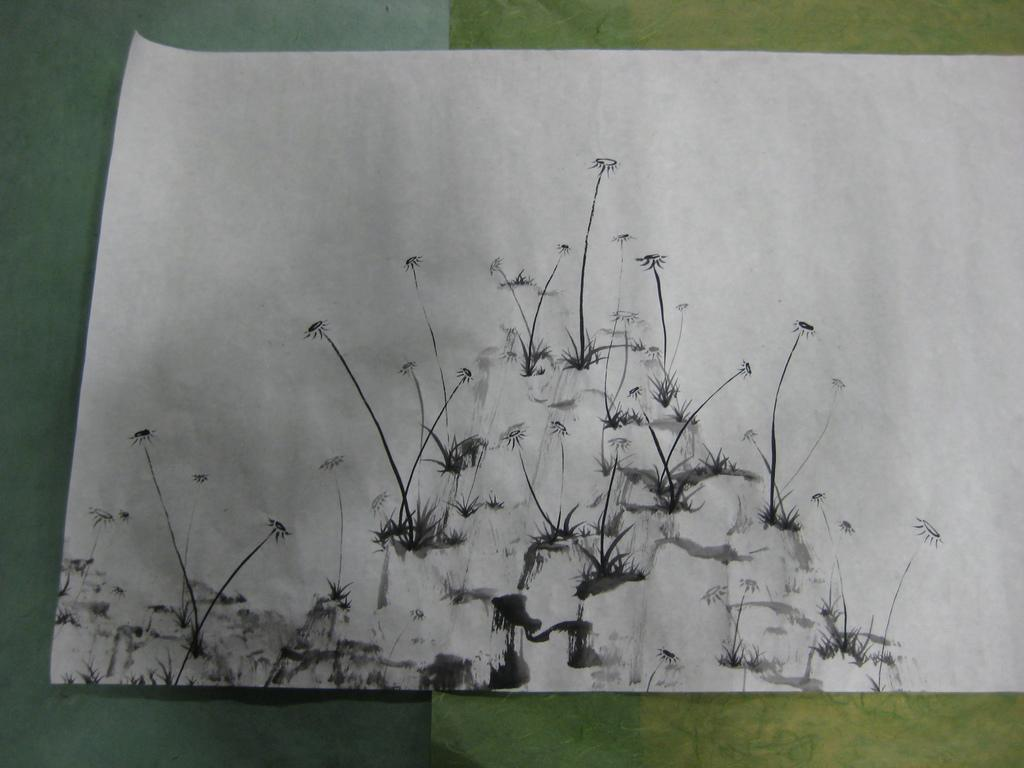What is the color of the poster in the image? The poster in the image is white. Where is the poster located in the image? The poster is pasted on a wall. What type of quilt is being used to cover the poster in the image? There is no quilt present in the image; it only features a white poster pasted on a wall. Can you see any shoes or rats in the image? No, there are no shoes or rats visible in the image. 